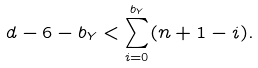<formula> <loc_0><loc_0><loc_500><loc_500>d - 6 - b _ { Y } < \sum _ { i = 0 } ^ { b _ { Y } } ( n + 1 - i ) .</formula> 